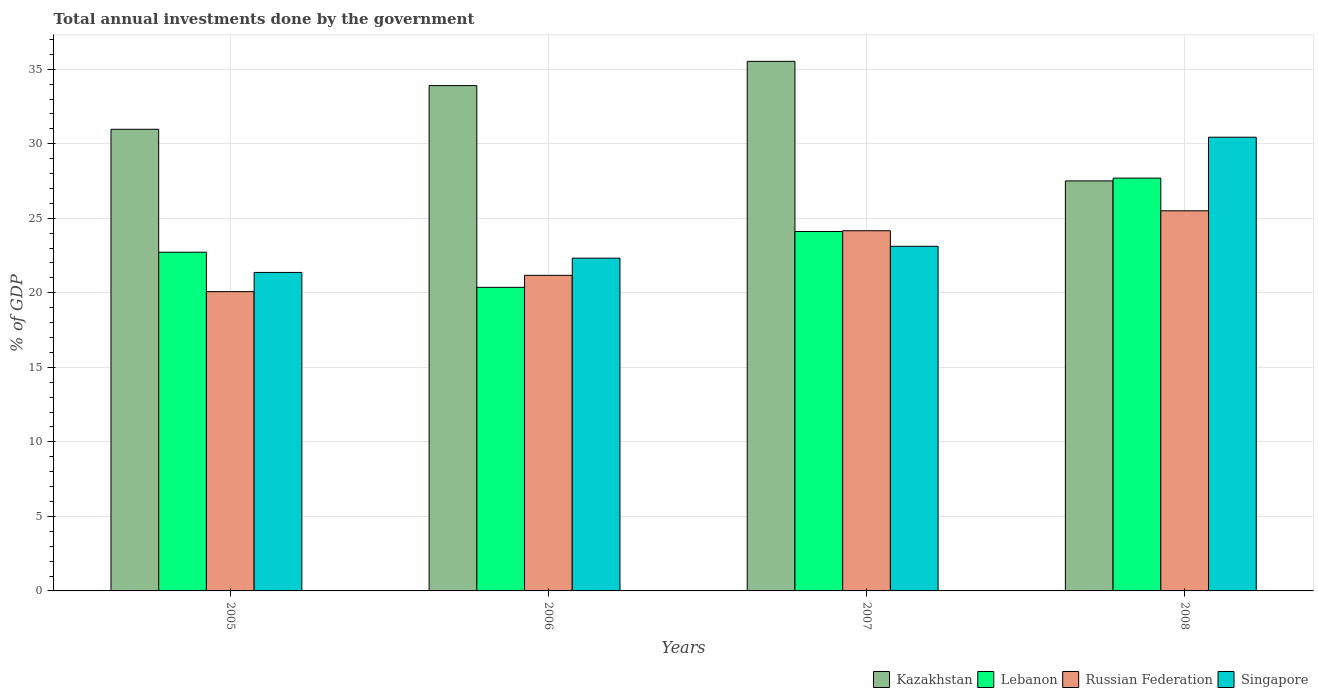How many different coloured bars are there?
Provide a short and direct response. 4. How many groups of bars are there?
Ensure brevity in your answer.  4. Are the number of bars on each tick of the X-axis equal?
Provide a succinct answer. Yes. What is the label of the 3rd group of bars from the left?
Make the answer very short. 2007. In how many cases, is the number of bars for a given year not equal to the number of legend labels?
Your answer should be very brief. 0. What is the total annual investments done by the government in Kazakhstan in 2006?
Make the answer very short. 33.9. Across all years, what is the maximum total annual investments done by the government in Kazakhstan?
Offer a terse response. 35.53. Across all years, what is the minimum total annual investments done by the government in Singapore?
Make the answer very short. 21.37. In which year was the total annual investments done by the government in Lebanon maximum?
Your answer should be compact. 2008. In which year was the total annual investments done by the government in Russian Federation minimum?
Ensure brevity in your answer.  2005. What is the total total annual investments done by the government in Lebanon in the graph?
Provide a succinct answer. 94.89. What is the difference between the total annual investments done by the government in Kazakhstan in 2007 and that in 2008?
Keep it short and to the point. 8.02. What is the difference between the total annual investments done by the government in Kazakhstan in 2008 and the total annual investments done by the government in Russian Federation in 2005?
Your answer should be compact. 7.43. What is the average total annual investments done by the government in Singapore per year?
Offer a terse response. 24.31. In the year 2007, what is the difference between the total annual investments done by the government in Lebanon and total annual investments done by the government in Singapore?
Provide a succinct answer. 0.99. What is the ratio of the total annual investments done by the government in Singapore in 2006 to that in 2007?
Give a very brief answer. 0.97. Is the total annual investments done by the government in Kazakhstan in 2005 less than that in 2008?
Provide a short and direct response. No. What is the difference between the highest and the second highest total annual investments done by the government in Kazakhstan?
Give a very brief answer. 1.63. What is the difference between the highest and the lowest total annual investments done by the government in Lebanon?
Give a very brief answer. 7.33. In how many years, is the total annual investments done by the government in Lebanon greater than the average total annual investments done by the government in Lebanon taken over all years?
Make the answer very short. 2. What does the 2nd bar from the left in 2007 represents?
Make the answer very short. Lebanon. What does the 2nd bar from the right in 2005 represents?
Make the answer very short. Russian Federation. Is it the case that in every year, the sum of the total annual investments done by the government in Russian Federation and total annual investments done by the government in Lebanon is greater than the total annual investments done by the government in Singapore?
Your answer should be compact. Yes. What is the difference between two consecutive major ticks on the Y-axis?
Give a very brief answer. 5. Does the graph contain grids?
Your answer should be compact. Yes. Where does the legend appear in the graph?
Your answer should be compact. Bottom right. How many legend labels are there?
Your answer should be compact. 4. How are the legend labels stacked?
Offer a terse response. Horizontal. What is the title of the graph?
Offer a terse response. Total annual investments done by the government. Does "Lao PDR" appear as one of the legend labels in the graph?
Your response must be concise. No. What is the label or title of the X-axis?
Your answer should be compact. Years. What is the label or title of the Y-axis?
Give a very brief answer. % of GDP. What is the % of GDP in Kazakhstan in 2005?
Keep it short and to the point. 30.97. What is the % of GDP of Lebanon in 2005?
Provide a short and direct response. 22.72. What is the % of GDP of Russian Federation in 2005?
Provide a succinct answer. 20.08. What is the % of GDP in Singapore in 2005?
Offer a very short reply. 21.37. What is the % of GDP of Kazakhstan in 2006?
Your response must be concise. 33.9. What is the % of GDP in Lebanon in 2006?
Provide a short and direct response. 20.37. What is the % of GDP of Russian Federation in 2006?
Ensure brevity in your answer.  21.17. What is the % of GDP of Singapore in 2006?
Provide a short and direct response. 22.32. What is the % of GDP in Kazakhstan in 2007?
Your response must be concise. 35.53. What is the % of GDP in Lebanon in 2007?
Provide a succinct answer. 24.11. What is the % of GDP of Russian Federation in 2007?
Give a very brief answer. 24.16. What is the % of GDP of Singapore in 2007?
Keep it short and to the point. 23.12. What is the % of GDP of Kazakhstan in 2008?
Offer a terse response. 27.51. What is the % of GDP in Lebanon in 2008?
Give a very brief answer. 27.69. What is the % of GDP in Russian Federation in 2008?
Offer a very short reply. 25.5. What is the % of GDP of Singapore in 2008?
Your response must be concise. 30.44. Across all years, what is the maximum % of GDP of Kazakhstan?
Give a very brief answer. 35.53. Across all years, what is the maximum % of GDP of Lebanon?
Ensure brevity in your answer.  27.69. Across all years, what is the maximum % of GDP in Russian Federation?
Your answer should be compact. 25.5. Across all years, what is the maximum % of GDP in Singapore?
Offer a very short reply. 30.44. Across all years, what is the minimum % of GDP in Kazakhstan?
Give a very brief answer. 27.51. Across all years, what is the minimum % of GDP of Lebanon?
Keep it short and to the point. 20.37. Across all years, what is the minimum % of GDP of Russian Federation?
Provide a succinct answer. 20.08. Across all years, what is the minimum % of GDP of Singapore?
Your answer should be very brief. 21.37. What is the total % of GDP in Kazakhstan in the graph?
Your response must be concise. 127.9. What is the total % of GDP in Lebanon in the graph?
Offer a terse response. 94.89. What is the total % of GDP of Russian Federation in the graph?
Your answer should be compact. 90.91. What is the total % of GDP of Singapore in the graph?
Keep it short and to the point. 97.25. What is the difference between the % of GDP of Kazakhstan in 2005 and that in 2006?
Ensure brevity in your answer.  -2.93. What is the difference between the % of GDP in Lebanon in 2005 and that in 2006?
Your answer should be very brief. 2.36. What is the difference between the % of GDP of Russian Federation in 2005 and that in 2006?
Make the answer very short. -1.09. What is the difference between the % of GDP of Singapore in 2005 and that in 2006?
Ensure brevity in your answer.  -0.96. What is the difference between the % of GDP of Kazakhstan in 2005 and that in 2007?
Your response must be concise. -4.56. What is the difference between the % of GDP of Lebanon in 2005 and that in 2007?
Provide a short and direct response. -1.39. What is the difference between the % of GDP of Russian Federation in 2005 and that in 2007?
Provide a succinct answer. -4.09. What is the difference between the % of GDP of Singapore in 2005 and that in 2007?
Your answer should be very brief. -1.75. What is the difference between the % of GDP in Kazakhstan in 2005 and that in 2008?
Make the answer very short. 3.46. What is the difference between the % of GDP of Lebanon in 2005 and that in 2008?
Provide a succinct answer. -4.97. What is the difference between the % of GDP in Russian Federation in 2005 and that in 2008?
Give a very brief answer. -5.42. What is the difference between the % of GDP of Singapore in 2005 and that in 2008?
Your response must be concise. -9.07. What is the difference between the % of GDP of Kazakhstan in 2006 and that in 2007?
Provide a short and direct response. -1.63. What is the difference between the % of GDP in Lebanon in 2006 and that in 2007?
Your response must be concise. -3.74. What is the difference between the % of GDP in Russian Federation in 2006 and that in 2007?
Offer a terse response. -2.99. What is the difference between the % of GDP of Singapore in 2006 and that in 2007?
Keep it short and to the point. -0.8. What is the difference between the % of GDP in Kazakhstan in 2006 and that in 2008?
Ensure brevity in your answer.  6.39. What is the difference between the % of GDP of Lebanon in 2006 and that in 2008?
Make the answer very short. -7.33. What is the difference between the % of GDP of Russian Federation in 2006 and that in 2008?
Give a very brief answer. -4.33. What is the difference between the % of GDP of Singapore in 2006 and that in 2008?
Your answer should be compact. -8.11. What is the difference between the % of GDP in Kazakhstan in 2007 and that in 2008?
Give a very brief answer. 8.02. What is the difference between the % of GDP in Lebanon in 2007 and that in 2008?
Offer a terse response. -3.58. What is the difference between the % of GDP of Russian Federation in 2007 and that in 2008?
Offer a terse response. -1.34. What is the difference between the % of GDP in Singapore in 2007 and that in 2008?
Give a very brief answer. -7.32. What is the difference between the % of GDP of Kazakhstan in 2005 and the % of GDP of Lebanon in 2006?
Your response must be concise. 10.6. What is the difference between the % of GDP in Kazakhstan in 2005 and the % of GDP in Russian Federation in 2006?
Ensure brevity in your answer.  9.8. What is the difference between the % of GDP in Kazakhstan in 2005 and the % of GDP in Singapore in 2006?
Provide a short and direct response. 8.65. What is the difference between the % of GDP of Lebanon in 2005 and the % of GDP of Russian Federation in 2006?
Offer a very short reply. 1.55. What is the difference between the % of GDP in Lebanon in 2005 and the % of GDP in Singapore in 2006?
Your answer should be compact. 0.4. What is the difference between the % of GDP in Russian Federation in 2005 and the % of GDP in Singapore in 2006?
Keep it short and to the point. -2.25. What is the difference between the % of GDP in Kazakhstan in 2005 and the % of GDP in Lebanon in 2007?
Your answer should be compact. 6.86. What is the difference between the % of GDP in Kazakhstan in 2005 and the % of GDP in Russian Federation in 2007?
Ensure brevity in your answer.  6.81. What is the difference between the % of GDP of Kazakhstan in 2005 and the % of GDP of Singapore in 2007?
Your answer should be very brief. 7.85. What is the difference between the % of GDP of Lebanon in 2005 and the % of GDP of Russian Federation in 2007?
Your response must be concise. -1.44. What is the difference between the % of GDP in Lebanon in 2005 and the % of GDP in Singapore in 2007?
Your response must be concise. -0.4. What is the difference between the % of GDP of Russian Federation in 2005 and the % of GDP of Singapore in 2007?
Give a very brief answer. -3.04. What is the difference between the % of GDP in Kazakhstan in 2005 and the % of GDP in Lebanon in 2008?
Ensure brevity in your answer.  3.28. What is the difference between the % of GDP in Kazakhstan in 2005 and the % of GDP in Russian Federation in 2008?
Ensure brevity in your answer.  5.47. What is the difference between the % of GDP of Kazakhstan in 2005 and the % of GDP of Singapore in 2008?
Provide a succinct answer. 0.53. What is the difference between the % of GDP in Lebanon in 2005 and the % of GDP in Russian Federation in 2008?
Your response must be concise. -2.78. What is the difference between the % of GDP of Lebanon in 2005 and the % of GDP of Singapore in 2008?
Keep it short and to the point. -7.71. What is the difference between the % of GDP in Russian Federation in 2005 and the % of GDP in Singapore in 2008?
Your answer should be compact. -10.36. What is the difference between the % of GDP in Kazakhstan in 2006 and the % of GDP in Lebanon in 2007?
Provide a succinct answer. 9.79. What is the difference between the % of GDP in Kazakhstan in 2006 and the % of GDP in Russian Federation in 2007?
Make the answer very short. 9.74. What is the difference between the % of GDP in Kazakhstan in 2006 and the % of GDP in Singapore in 2007?
Offer a very short reply. 10.78. What is the difference between the % of GDP of Lebanon in 2006 and the % of GDP of Russian Federation in 2007?
Your answer should be compact. -3.8. What is the difference between the % of GDP of Lebanon in 2006 and the % of GDP of Singapore in 2007?
Provide a succinct answer. -2.75. What is the difference between the % of GDP of Russian Federation in 2006 and the % of GDP of Singapore in 2007?
Keep it short and to the point. -1.95. What is the difference between the % of GDP of Kazakhstan in 2006 and the % of GDP of Lebanon in 2008?
Your answer should be very brief. 6.21. What is the difference between the % of GDP of Kazakhstan in 2006 and the % of GDP of Russian Federation in 2008?
Make the answer very short. 8.4. What is the difference between the % of GDP of Kazakhstan in 2006 and the % of GDP of Singapore in 2008?
Make the answer very short. 3.46. What is the difference between the % of GDP of Lebanon in 2006 and the % of GDP of Russian Federation in 2008?
Offer a terse response. -5.13. What is the difference between the % of GDP in Lebanon in 2006 and the % of GDP in Singapore in 2008?
Your response must be concise. -10.07. What is the difference between the % of GDP of Russian Federation in 2006 and the % of GDP of Singapore in 2008?
Provide a succinct answer. -9.27. What is the difference between the % of GDP in Kazakhstan in 2007 and the % of GDP in Lebanon in 2008?
Your answer should be very brief. 7.83. What is the difference between the % of GDP of Kazakhstan in 2007 and the % of GDP of Russian Federation in 2008?
Offer a terse response. 10.03. What is the difference between the % of GDP of Kazakhstan in 2007 and the % of GDP of Singapore in 2008?
Ensure brevity in your answer.  5.09. What is the difference between the % of GDP in Lebanon in 2007 and the % of GDP in Russian Federation in 2008?
Provide a succinct answer. -1.39. What is the difference between the % of GDP of Lebanon in 2007 and the % of GDP of Singapore in 2008?
Your answer should be compact. -6.33. What is the difference between the % of GDP of Russian Federation in 2007 and the % of GDP of Singapore in 2008?
Keep it short and to the point. -6.27. What is the average % of GDP of Kazakhstan per year?
Keep it short and to the point. 31.98. What is the average % of GDP in Lebanon per year?
Make the answer very short. 23.72. What is the average % of GDP in Russian Federation per year?
Provide a short and direct response. 22.73. What is the average % of GDP of Singapore per year?
Give a very brief answer. 24.31. In the year 2005, what is the difference between the % of GDP in Kazakhstan and % of GDP in Lebanon?
Your response must be concise. 8.25. In the year 2005, what is the difference between the % of GDP of Kazakhstan and % of GDP of Russian Federation?
Offer a very short reply. 10.89. In the year 2005, what is the difference between the % of GDP in Kazakhstan and % of GDP in Singapore?
Your answer should be compact. 9.6. In the year 2005, what is the difference between the % of GDP in Lebanon and % of GDP in Russian Federation?
Your response must be concise. 2.65. In the year 2005, what is the difference between the % of GDP of Lebanon and % of GDP of Singapore?
Your answer should be very brief. 1.36. In the year 2005, what is the difference between the % of GDP of Russian Federation and % of GDP of Singapore?
Your response must be concise. -1.29. In the year 2006, what is the difference between the % of GDP in Kazakhstan and % of GDP in Lebanon?
Your answer should be compact. 13.53. In the year 2006, what is the difference between the % of GDP in Kazakhstan and % of GDP in Russian Federation?
Offer a terse response. 12.73. In the year 2006, what is the difference between the % of GDP of Kazakhstan and % of GDP of Singapore?
Your answer should be very brief. 11.58. In the year 2006, what is the difference between the % of GDP of Lebanon and % of GDP of Russian Federation?
Your answer should be compact. -0.81. In the year 2006, what is the difference between the % of GDP in Lebanon and % of GDP in Singapore?
Your answer should be compact. -1.96. In the year 2006, what is the difference between the % of GDP of Russian Federation and % of GDP of Singapore?
Make the answer very short. -1.15. In the year 2007, what is the difference between the % of GDP in Kazakhstan and % of GDP in Lebanon?
Offer a very short reply. 11.42. In the year 2007, what is the difference between the % of GDP in Kazakhstan and % of GDP in Russian Federation?
Your response must be concise. 11.36. In the year 2007, what is the difference between the % of GDP in Kazakhstan and % of GDP in Singapore?
Keep it short and to the point. 12.41. In the year 2007, what is the difference between the % of GDP in Lebanon and % of GDP in Russian Federation?
Your answer should be very brief. -0.05. In the year 2007, what is the difference between the % of GDP in Lebanon and % of GDP in Singapore?
Keep it short and to the point. 0.99. In the year 2007, what is the difference between the % of GDP in Russian Federation and % of GDP in Singapore?
Ensure brevity in your answer.  1.04. In the year 2008, what is the difference between the % of GDP in Kazakhstan and % of GDP in Lebanon?
Provide a short and direct response. -0.19. In the year 2008, what is the difference between the % of GDP in Kazakhstan and % of GDP in Russian Federation?
Offer a very short reply. 2.01. In the year 2008, what is the difference between the % of GDP of Kazakhstan and % of GDP of Singapore?
Provide a short and direct response. -2.93. In the year 2008, what is the difference between the % of GDP in Lebanon and % of GDP in Russian Federation?
Provide a short and direct response. 2.19. In the year 2008, what is the difference between the % of GDP of Lebanon and % of GDP of Singapore?
Offer a very short reply. -2.74. In the year 2008, what is the difference between the % of GDP of Russian Federation and % of GDP of Singapore?
Your answer should be very brief. -4.94. What is the ratio of the % of GDP in Kazakhstan in 2005 to that in 2006?
Provide a succinct answer. 0.91. What is the ratio of the % of GDP of Lebanon in 2005 to that in 2006?
Your answer should be compact. 1.12. What is the ratio of the % of GDP of Russian Federation in 2005 to that in 2006?
Provide a short and direct response. 0.95. What is the ratio of the % of GDP in Singapore in 2005 to that in 2006?
Make the answer very short. 0.96. What is the ratio of the % of GDP in Kazakhstan in 2005 to that in 2007?
Your answer should be compact. 0.87. What is the ratio of the % of GDP of Lebanon in 2005 to that in 2007?
Make the answer very short. 0.94. What is the ratio of the % of GDP in Russian Federation in 2005 to that in 2007?
Make the answer very short. 0.83. What is the ratio of the % of GDP of Singapore in 2005 to that in 2007?
Your answer should be compact. 0.92. What is the ratio of the % of GDP of Kazakhstan in 2005 to that in 2008?
Offer a terse response. 1.13. What is the ratio of the % of GDP in Lebanon in 2005 to that in 2008?
Make the answer very short. 0.82. What is the ratio of the % of GDP in Russian Federation in 2005 to that in 2008?
Provide a short and direct response. 0.79. What is the ratio of the % of GDP in Singapore in 2005 to that in 2008?
Make the answer very short. 0.7. What is the ratio of the % of GDP in Kazakhstan in 2006 to that in 2007?
Keep it short and to the point. 0.95. What is the ratio of the % of GDP in Lebanon in 2006 to that in 2007?
Your answer should be compact. 0.84. What is the ratio of the % of GDP in Russian Federation in 2006 to that in 2007?
Your answer should be compact. 0.88. What is the ratio of the % of GDP in Singapore in 2006 to that in 2007?
Provide a short and direct response. 0.97. What is the ratio of the % of GDP in Kazakhstan in 2006 to that in 2008?
Offer a very short reply. 1.23. What is the ratio of the % of GDP in Lebanon in 2006 to that in 2008?
Your response must be concise. 0.74. What is the ratio of the % of GDP of Russian Federation in 2006 to that in 2008?
Make the answer very short. 0.83. What is the ratio of the % of GDP in Singapore in 2006 to that in 2008?
Your answer should be very brief. 0.73. What is the ratio of the % of GDP in Kazakhstan in 2007 to that in 2008?
Offer a very short reply. 1.29. What is the ratio of the % of GDP in Lebanon in 2007 to that in 2008?
Your answer should be very brief. 0.87. What is the ratio of the % of GDP of Russian Federation in 2007 to that in 2008?
Make the answer very short. 0.95. What is the ratio of the % of GDP of Singapore in 2007 to that in 2008?
Your response must be concise. 0.76. What is the difference between the highest and the second highest % of GDP of Kazakhstan?
Give a very brief answer. 1.63. What is the difference between the highest and the second highest % of GDP in Lebanon?
Offer a terse response. 3.58. What is the difference between the highest and the second highest % of GDP of Russian Federation?
Offer a very short reply. 1.34. What is the difference between the highest and the second highest % of GDP in Singapore?
Your answer should be compact. 7.32. What is the difference between the highest and the lowest % of GDP in Kazakhstan?
Ensure brevity in your answer.  8.02. What is the difference between the highest and the lowest % of GDP in Lebanon?
Provide a short and direct response. 7.33. What is the difference between the highest and the lowest % of GDP of Russian Federation?
Ensure brevity in your answer.  5.42. What is the difference between the highest and the lowest % of GDP in Singapore?
Your answer should be very brief. 9.07. 